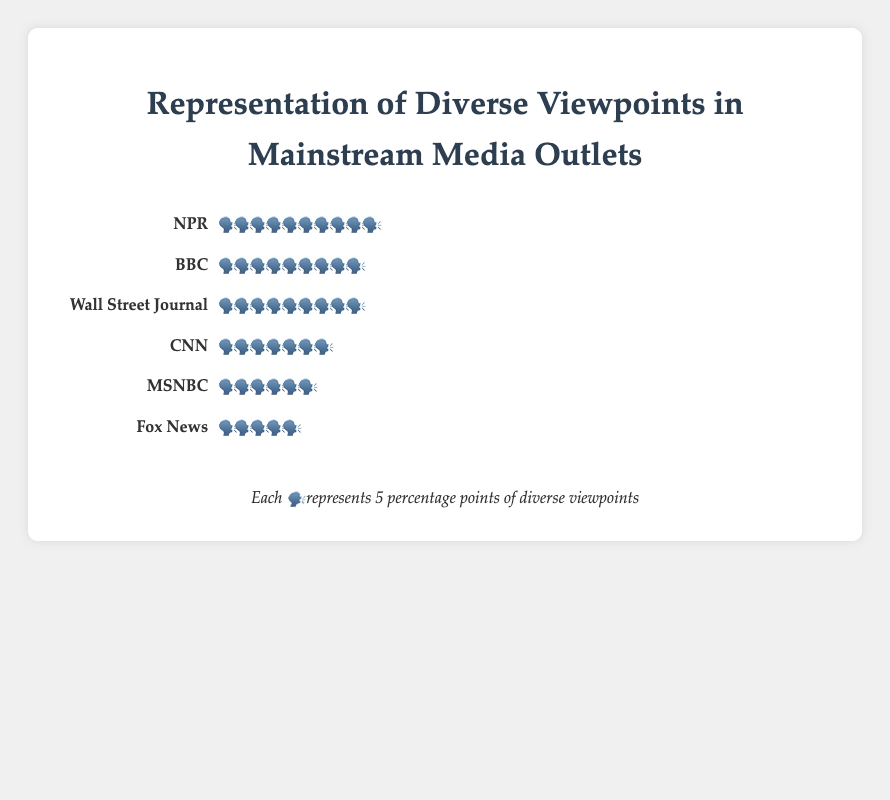What is the title of the figure? The title should be positioned prominently, typically at the top center of the figure, and it provides a summary of what the plot represents.
Answer: Representation of Diverse Viewpoints in Mainstream Media Outlets Which media outlet has the highest representation of diverse viewpoints? By examining each row in the plot, we notice NPR has the most repeated symbols 🗣️, indicating the highest representation of diverse viewpoints.
Answer: NPR How many units of diverse viewpoints does Fox News have? Each unit represents 5 percentage points, and Fox News has 5 symbols. Therefore, the total is 5 * 5 = 25, but the data indicates 28, so rounding might have occurred for visual representation.
Answer: 28 What is the sum of diverse viewpoints of MSNBC and CNN? MSNBC has 6 symbols (6 * 5 = 30) and CNN has 7 symbols (7 * 5 = 35). Summing these values yields 30 + 35 = 65.
Answer: 65 Which media outlet ranks second in terms of diverse viewpoints? By observing the number of symbols in decreasing order, BBC is the second with 9 symbols corresponding to 45 percentage points.
Answer: BBC Compare the difference in diverse viewpoints between NPR and Wall Street Journal. NPR has 52 points, and Wall Street Journal has 45 points. By subtracting these values, 52 - 45 = 7.
Answer: 7 How many total units of diverse viewpoints are represented across all media outlets? Summing all units: CNN (7) + Fox News (5) + MSNBC (6) + BBC (9) + NPR (10) + Wall Street Journal (9) equals 46 symbols. Each symbol equals 5 points, so 46 * 5 = 230.
Answer: 230 What is the average number of diverse viewpoints for all media outlets? Total viewpoints across all outlets is 230. Dividing by the number of outlets, 230 / 6 ≈ 38.33.
Answer: 38.33 Which two media outlets have the most similar representation of diverse viewpoints? Wall Street Journal and BBC both have 9 symbols, making them the closest in representation.
Answer: Wall Street Journal and BBC What is the common unit representation in the figure and its value? The legend indicates the symbol 🗣️ represents 5 percentage points of diverse viewpoints.
Answer: 🗣️ and 5 points 